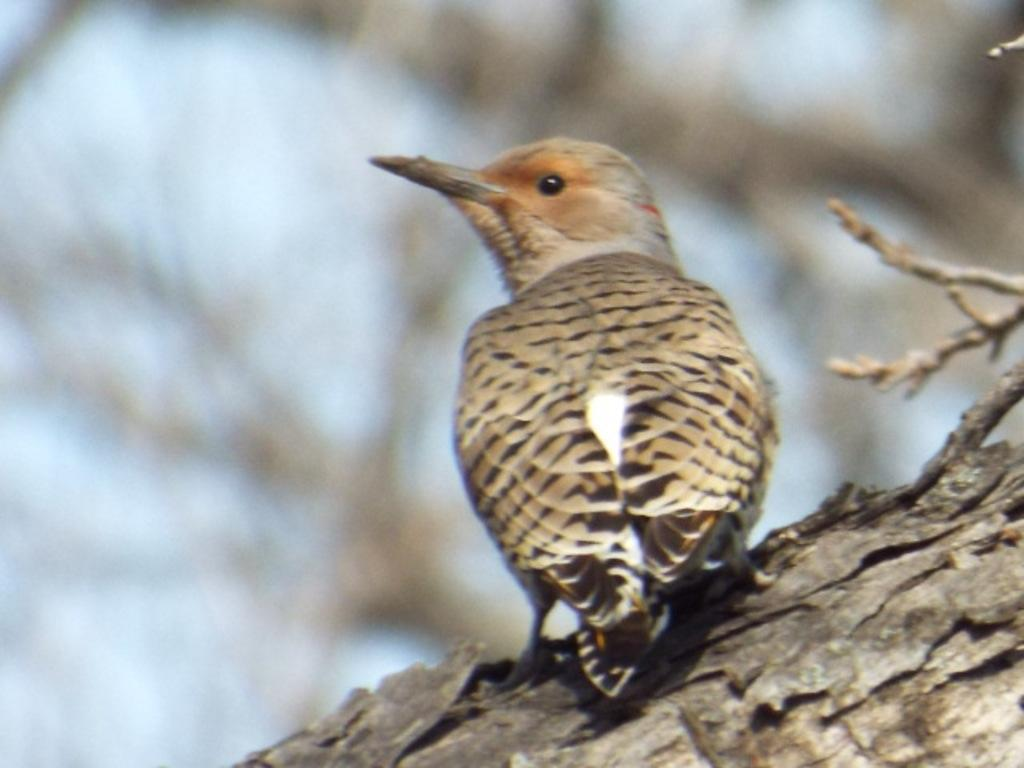What type of animal is in the image? There is a bird in the image. Can you describe the background of the image? The background of the image is blurred. What type of boot is the bird wearing in the image? There is no boot present in the image, as birds do not wear boots. 